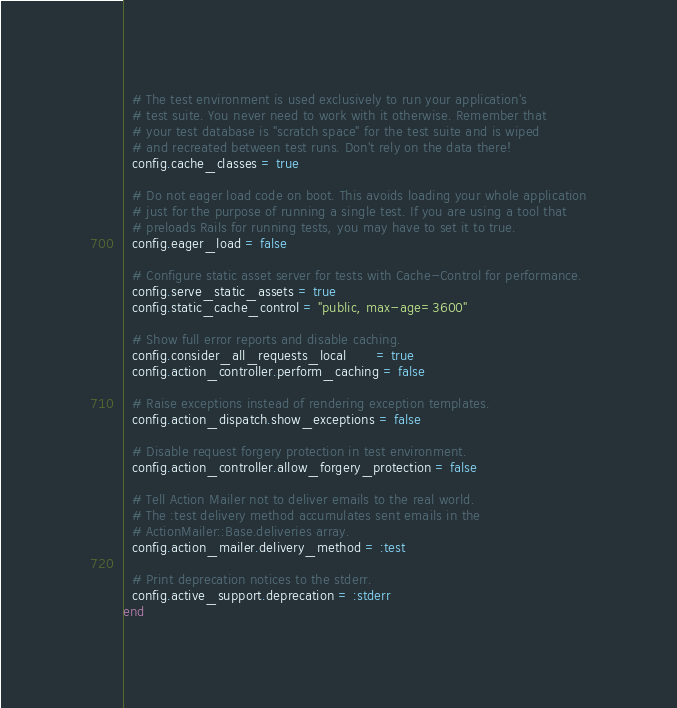<code> <loc_0><loc_0><loc_500><loc_500><_Ruby_>  # The test environment is used exclusively to run your application's
  # test suite. You never need to work with it otherwise. Remember that
  # your test database is "scratch space" for the test suite and is wiped
  # and recreated between test runs. Don't rely on the data there!
  config.cache_classes = true

  # Do not eager load code on boot. This avoids loading your whole application
  # just for the purpose of running a single test. If you are using a tool that
  # preloads Rails for running tests, you may have to set it to true.
  config.eager_load = false

  # Configure static asset server for tests with Cache-Control for performance.
  config.serve_static_assets = true
  config.static_cache_control = "public, max-age=3600"

  # Show full error reports and disable caching.
  config.consider_all_requests_local       = true
  config.action_controller.perform_caching = false

  # Raise exceptions instead of rendering exception templates.
  config.action_dispatch.show_exceptions = false

  # Disable request forgery protection in test environment.
  config.action_controller.allow_forgery_protection = false

  # Tell Action Mailer not to deliver emails to the real world.
  # The :test delivery method accumulates sent emails in the
  # ActionMailer::Base.deliveries array.
  config.action_mailer.delivery_method = :test

  # Print deprecation notices to the stderr.
  config.active_support.deprecation = :stderr
end
</code> 